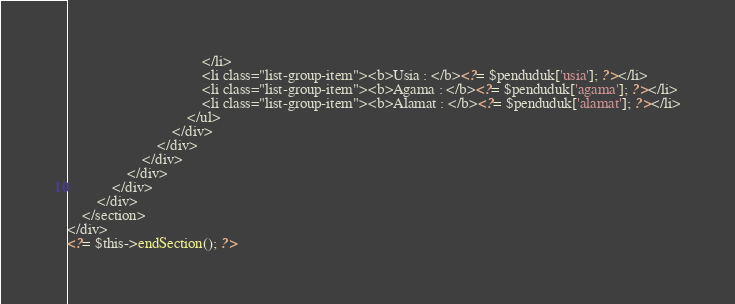Convert code to text. <code><loc_0><loc_0><loc_500><loc_500><_PHP_>                                    </li>
                                    <li class="list-group-item"><b>Usia : </b><?= $penduduk['usia']; ?></li>
                                    <li class="list-group-item"><b>Agama : </b><?= $penduduk['agama']; ?></li>
                                    <li class="list-group-item"><b>Alamat : </b><?= $penduduk['alamat']; ?></li>
                                </ul>
                            </div>
                        </div>
                    </div>
                </div>
            </div>
        </div>
    </section>
</div>
<?= $this->endSection(); ?></code> 